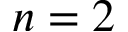Convert formula to latex. <formula><loc_0><loc_0><loc_500><loc_500>n = 2</formula> 